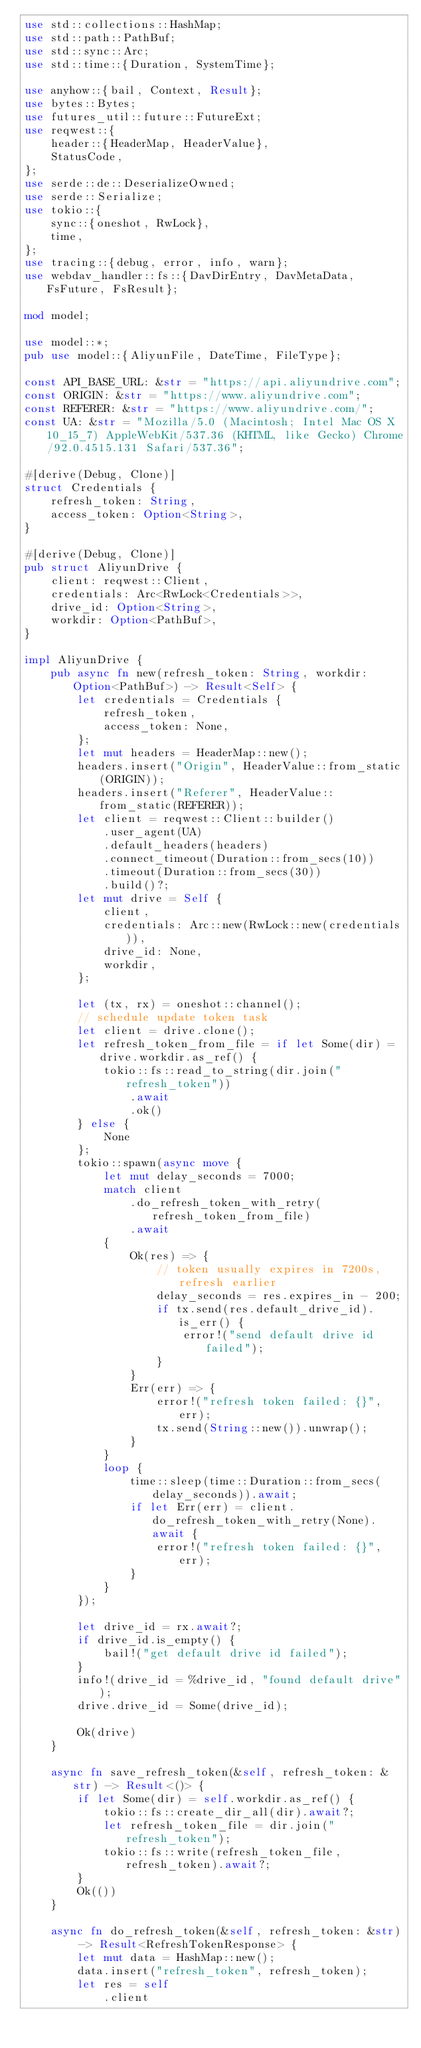<code> <loc_0><loc_0><loc_500><loc_500><_Rust_>use std::collections::HashMap;
use std::path::PathBuf;
use std::sync::Arc;
use std::time::{Duration, SystemTime};

use anyhow::{bail, Context, Result};
use bytes::Bytes;
use futures_util::future::FutureExt;
use reqwest::{
    header::{HeaderMap, HeaderValue},
    StatusCode,
};
use serde::de::DeserializeOwned;
use serde::Serialize;
use tokio::{
    sync::{oneshot, RwLock},
    time,
};
use tracing::{debug, error, info, warn};
use webdav_handler::fs::{DavDirEntry, DavMetaData, FsFuture, FsResult};

mod model;

use model::*;
pub use model::{AliyunFile, DateTime, FileType};

const API_BASE_URL: &str = "https://api.aliyundrive.com";
const ORIGIN: &str = "https://www.aliyundrive.com";
const REFERER: &str = "https://www.aliyundrive.com/";
const UA: &str = "Mozilla/5.0 (Macintosh; Intel Mac OS X 10_15_7) AppleWebKit/537.36 (KHTML, like Gecko) Chrome/92.0.4515.131 Safari/537.36";

#[derive(Debug, Clone)]
struct Credentials {
    refresh_token: String,
    access_token: Option<String>,
}

#[derive(Debug, Clone)]
pub struct AliyunDrive {
    client: reqwest::Client,
    credentials: Arc<RwLock<Credentials>>,
    drive_id: Option<String>,
    workdir: Option<PathBuf>,
}

impl AliyunDrive {
    pub async fn new(refresh_token: String, workdir: Option<PathBuf>) -> Result<Self> {
        let credentials = Credentials {
            refresh_token,
            access_token: None,
        };
        let mut headers = HeaderMap::new();
        headers.insert("Origin", HeaderValue::from_static(ORIGIN));
        headers.insert("Referer", HeaderValue::from_static(REFERER));
        let client = reqwest::Client::builder()
            .user_agent(UA)
            .default_headers(headers)
            .connect_timeout(Duration::from_secs(10))
            .timeout(Duration::from_secs(30))
            .build()?;
        let mut drive = Self {
            client,
            credentials: Arc::new(RwLock::new(credentials)),
            drive_id: None,
            workdir,
        };

        let (tx, rx) = oneshot::channel();
        // schedule update token task
        let client = drive.clone();
        let refresh_token_from_file = if let Some(dir) = drive.workdir.as_ref() {
            tokio::fs::read_to_string(dir.join("refresh_token"))
                .await
                .ok()
        } else {
            None
        };
        tokio::spawn(async move {
            let mut delay_seconds = 7000;
            match client
                .do_refresh_token_with_retry(refresh_token_from_file)
                .await
            {
                Ok(res) => {
                    // token usually expires in 7200s, refresh earlier
                    delay_seconds = res.expires_in - 200;
                    if tx.send(res.default_drive_id).is_err() {
                        error!("send default drive id failed");
                    }
                }
                Err(err) => {
                    error!("refresh token failed: {}", err);
                    tx.send(String::new()).unwrap();
                }
            }
            loop {
                time::sleep(time::Duration::from_secs(delay_seconds)).await;
                if let Err(err) = client.do_refresh_token_with_retry(None).await {
                    error!("refresh token failed: {}", err);
                }
            }
        });

        let drive_id = rx.await?;
        if drive_id.is_empty() {
            bail!("get default drive id failed");
        }
        info!(drive_id = %drive_id, "found default drive");
        drive.drive_id = Some(drive_id);

        Ok(drive)
    }

    async fn save_refresh_token(&self, refresh_token: &str) -> Result<()> {
        if let Some(dir) = self.workdir.as_ref() {
            tokio::fs::create_dir_all(dir).await?;
            let refresh_token_file = dir.join("refresh_token");
            tokio::fs::write(refresh_token_file, refresh_token).await?;
        }
        Ok(())
    }

    async fn do_refresh_token(&self, refresh_token: &str) -> Result<RefreshTokenResponse> {
        let mut data = HashMap::new();
        data.insert("refresh_token", refresh_token);
        let res = self
            .client</code> 